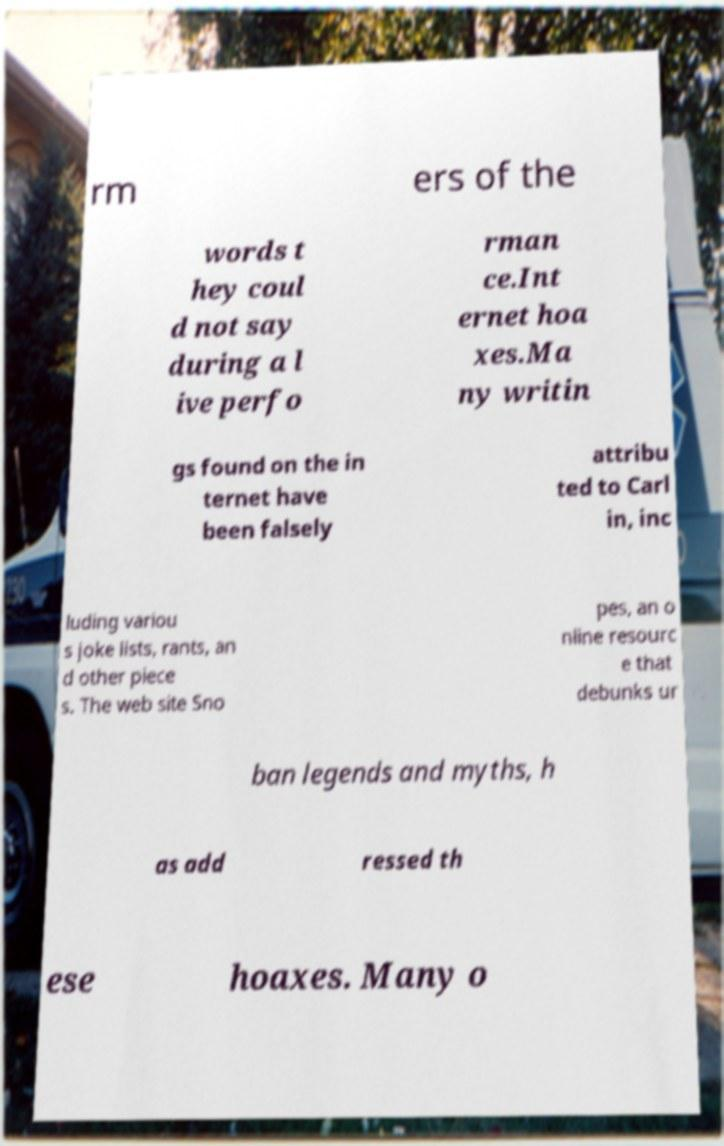What messages or text are displayed in this image? I need them in a readable, typed format. rm ers of the words t hey coul d not say during a l ive perfo rman ce.Int ernet hoa xes.Ma ny writin gs found on the in ternet have been falsely attribu ted to Carl in, inc luding variou s joke lists, rants, an d other piece s. The web site Sno pes, an o nline resourc e that debunks ur ban legends and myths, h as add ressed th ese hoaxes. Many o 